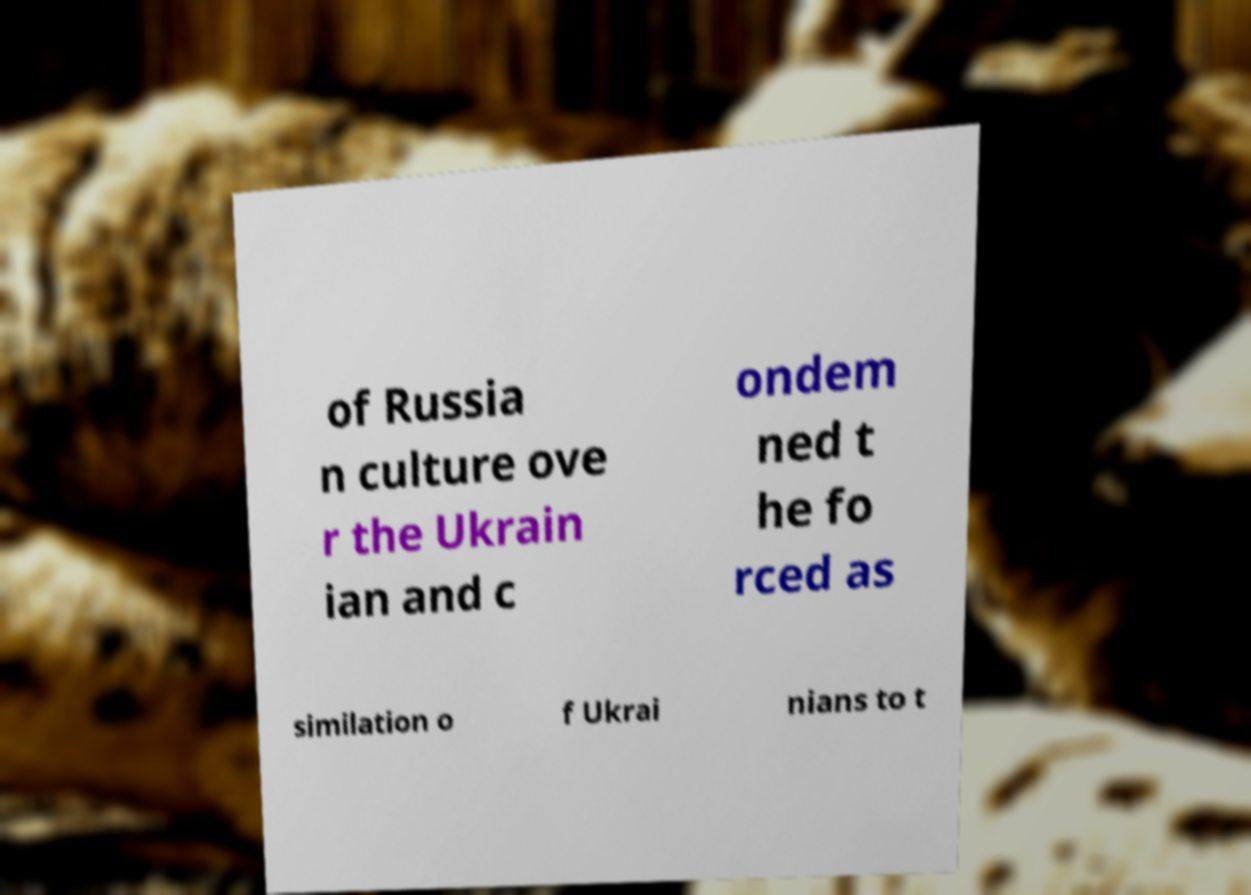Please read and relay the text visible in this image. What does it say? of Russia n culture ove r the Ukrain ian and c ondem ned t he fo rced as similation o f Ukrai nians to t 